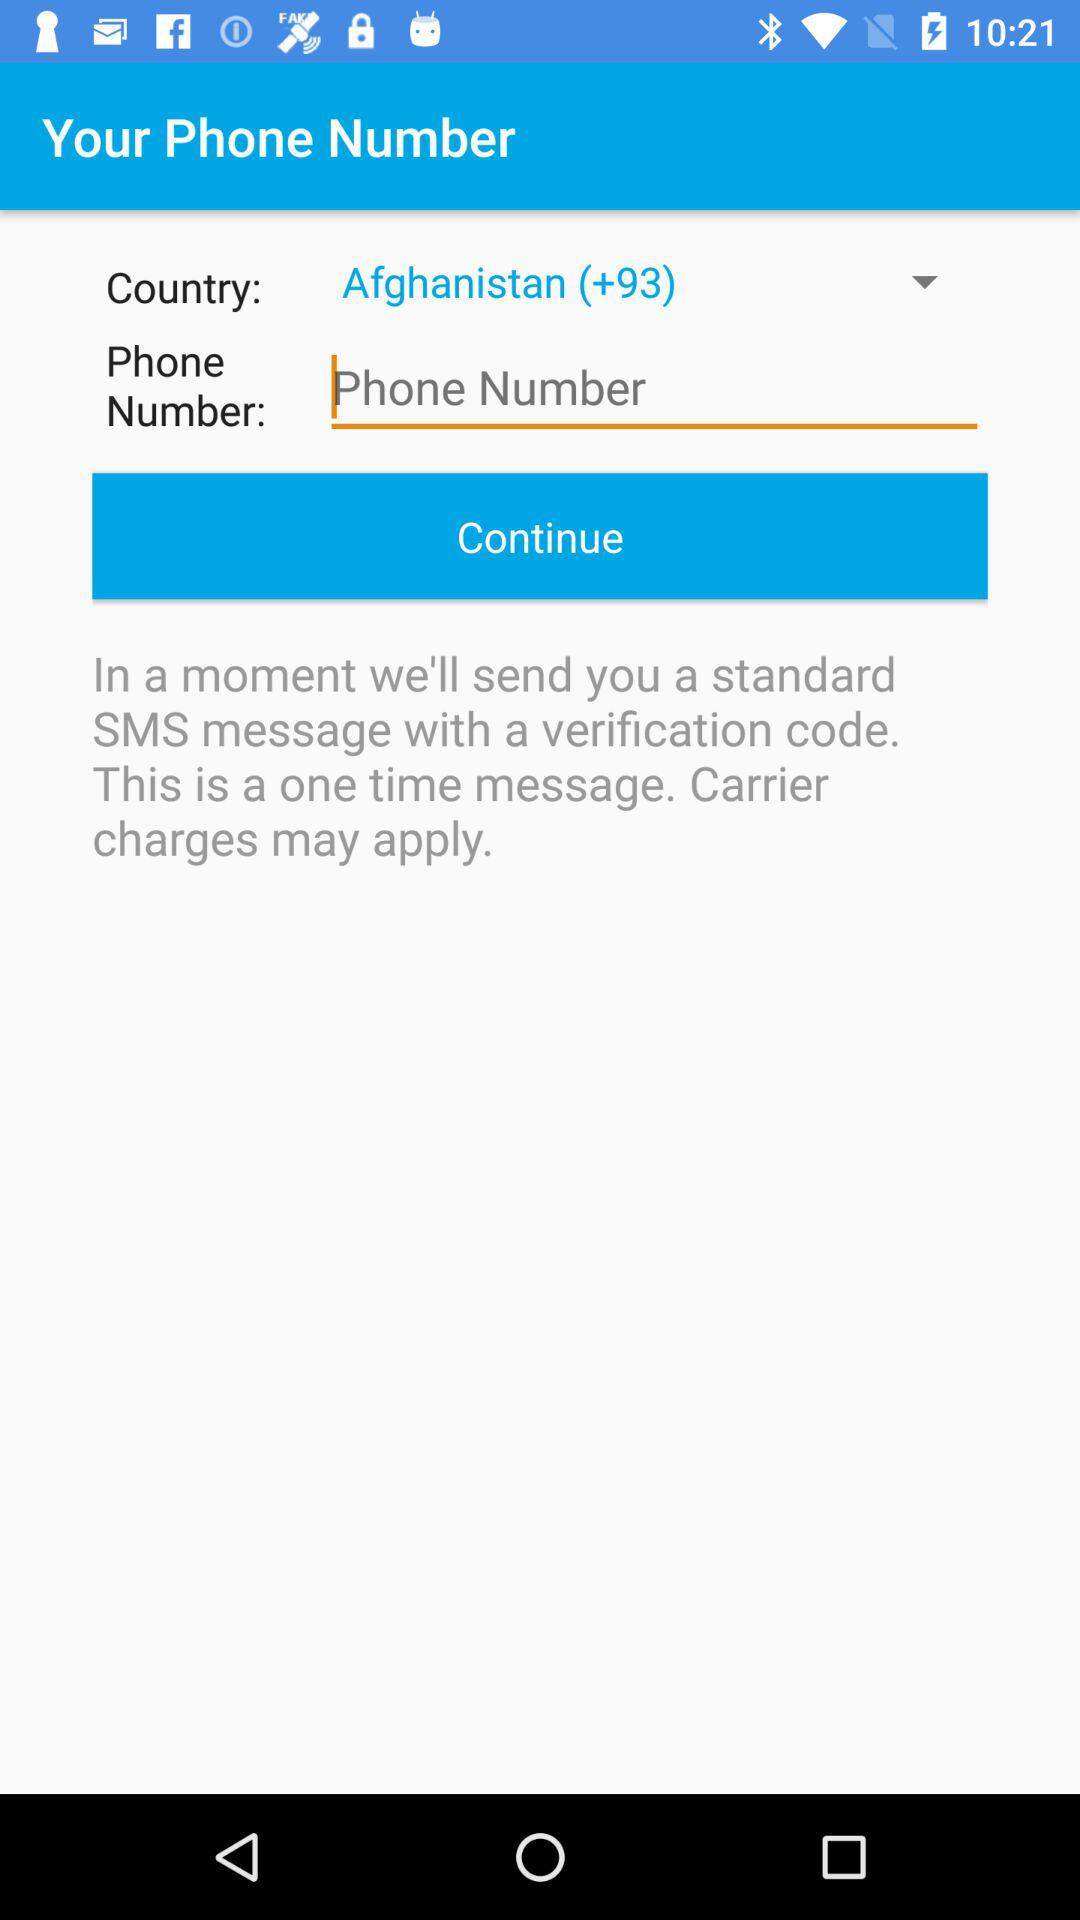Which is the selected country? The selected country is Afghanistan. 